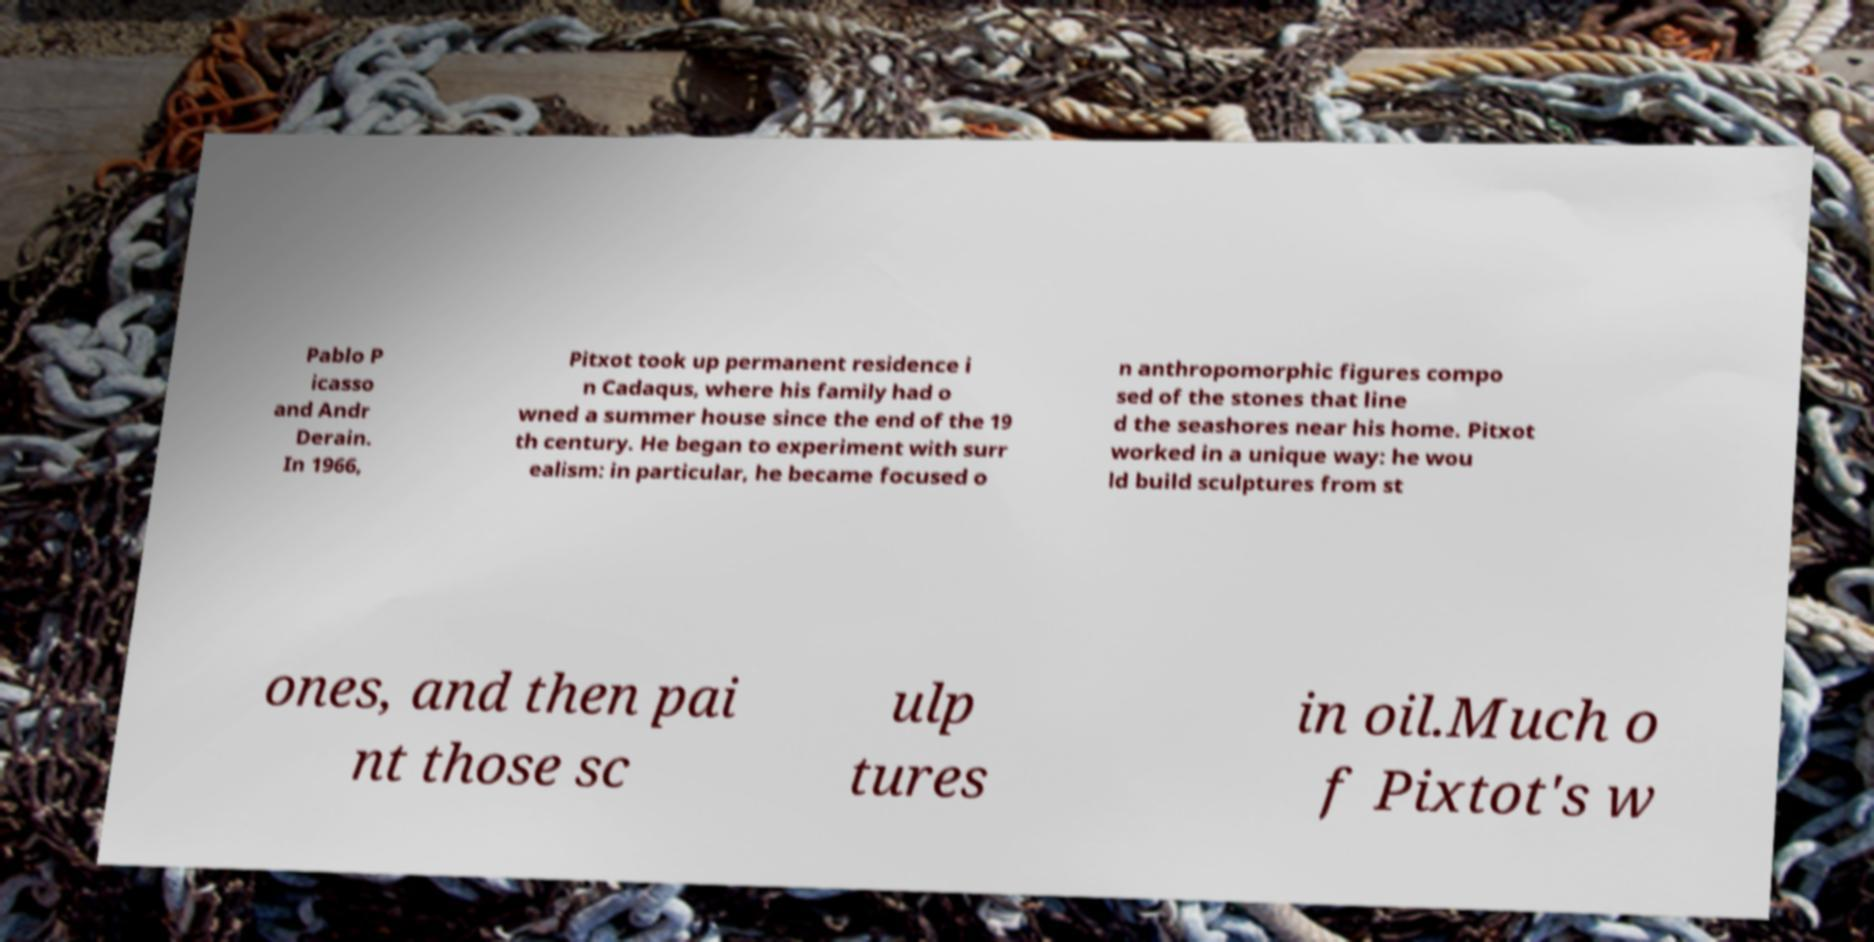Could you extract and type out the text from this image? Pablo P icasso and Andr Derain. In 1966, Pitxot took up permanent residence i n Cadaqus, where his family had o wned a summer house since the end of the 19 th century. He began to experiment with surr ealism: in particular, he became focused o n anthropomorphic figures compo sed of the stones that line d the seashores near his home. Pitxot worked in a unique way: he wou ld build sculptures from st ones, and then pai nt those sc ulp tures in oil.Much o f Pixtot's w 